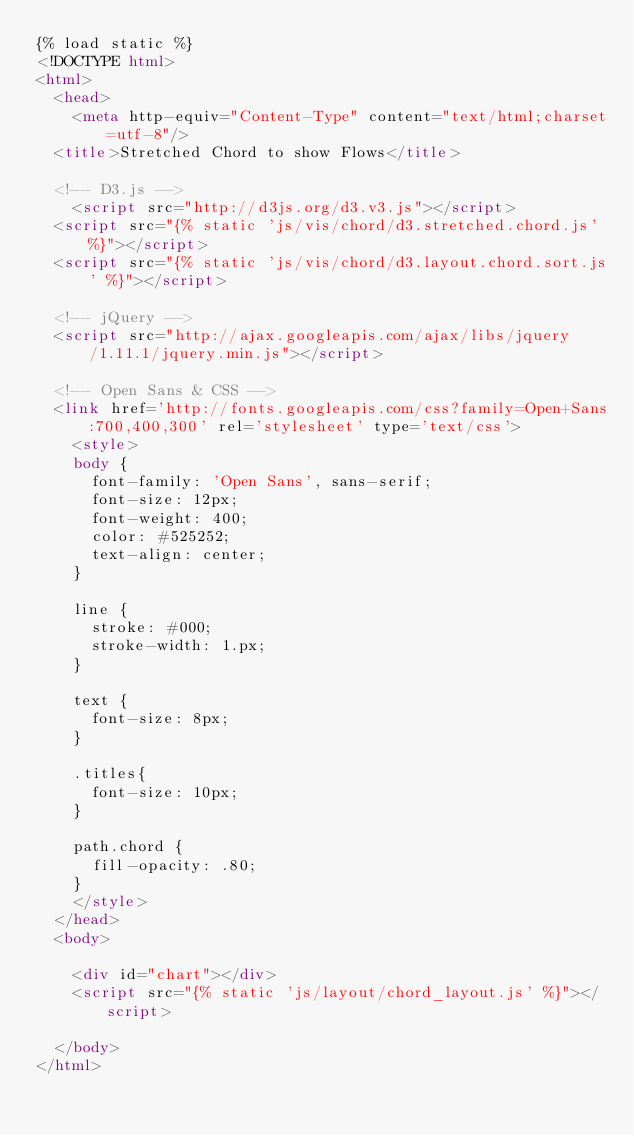Convert code to text. <code><loc_0><loc_0><loc_500><loc_500><_HTML_>{% load static %}
<!DOCTYPE html>
<html>
  <head>
    <meta http-equiv="Content-Type" content="text/html;charset=utf-8"/>
	<title>Stretched Chord to show Flows</title>

	<!-- D3.js -->	
    <script src="http://d3js.org/d3.v3.js"></script>
	<script src="{% static 'js/vis/chord/d3.stretched.chord.js' %}"></script>
	<script src="{% static 'js/vis/chord/d3.layout.chord.sort.js' %}"></script>
	
	<!-- jQuery -->
	<script src="http://ajax.googleapis.com/ajax/libs/jquery/1.11.1/jquery.min.js"></script>
	
	<!-- Open Sans & CSS -->
	<link href='http://fonts.googleapis.com/css?family=Open+Sans:700,400,300' rel='stylesheet' type='text/css'>
	  <style>
		body {
		  font-family: 'Open Sans', sans-serif;
		  font-size: 12px;
		  font-weight: 400;
		  color: #525252;
		  text-align: center;
		}	
		
		line {
		  stroke: #000;
		  stroke-width: 1.px;
		}

		text {
		  font-size: 8px;
		}

		.titles{
		  font-size: 10px;
		}

		path.chord {
		  fill-opacity: .80;
		}
	  </style>
  </head>
  <body>

    <div id="chart"></div>	
    <script src="{% static 'js/layout/chord_layout.js' %}"></script>
	
  </body>
</html></code> 